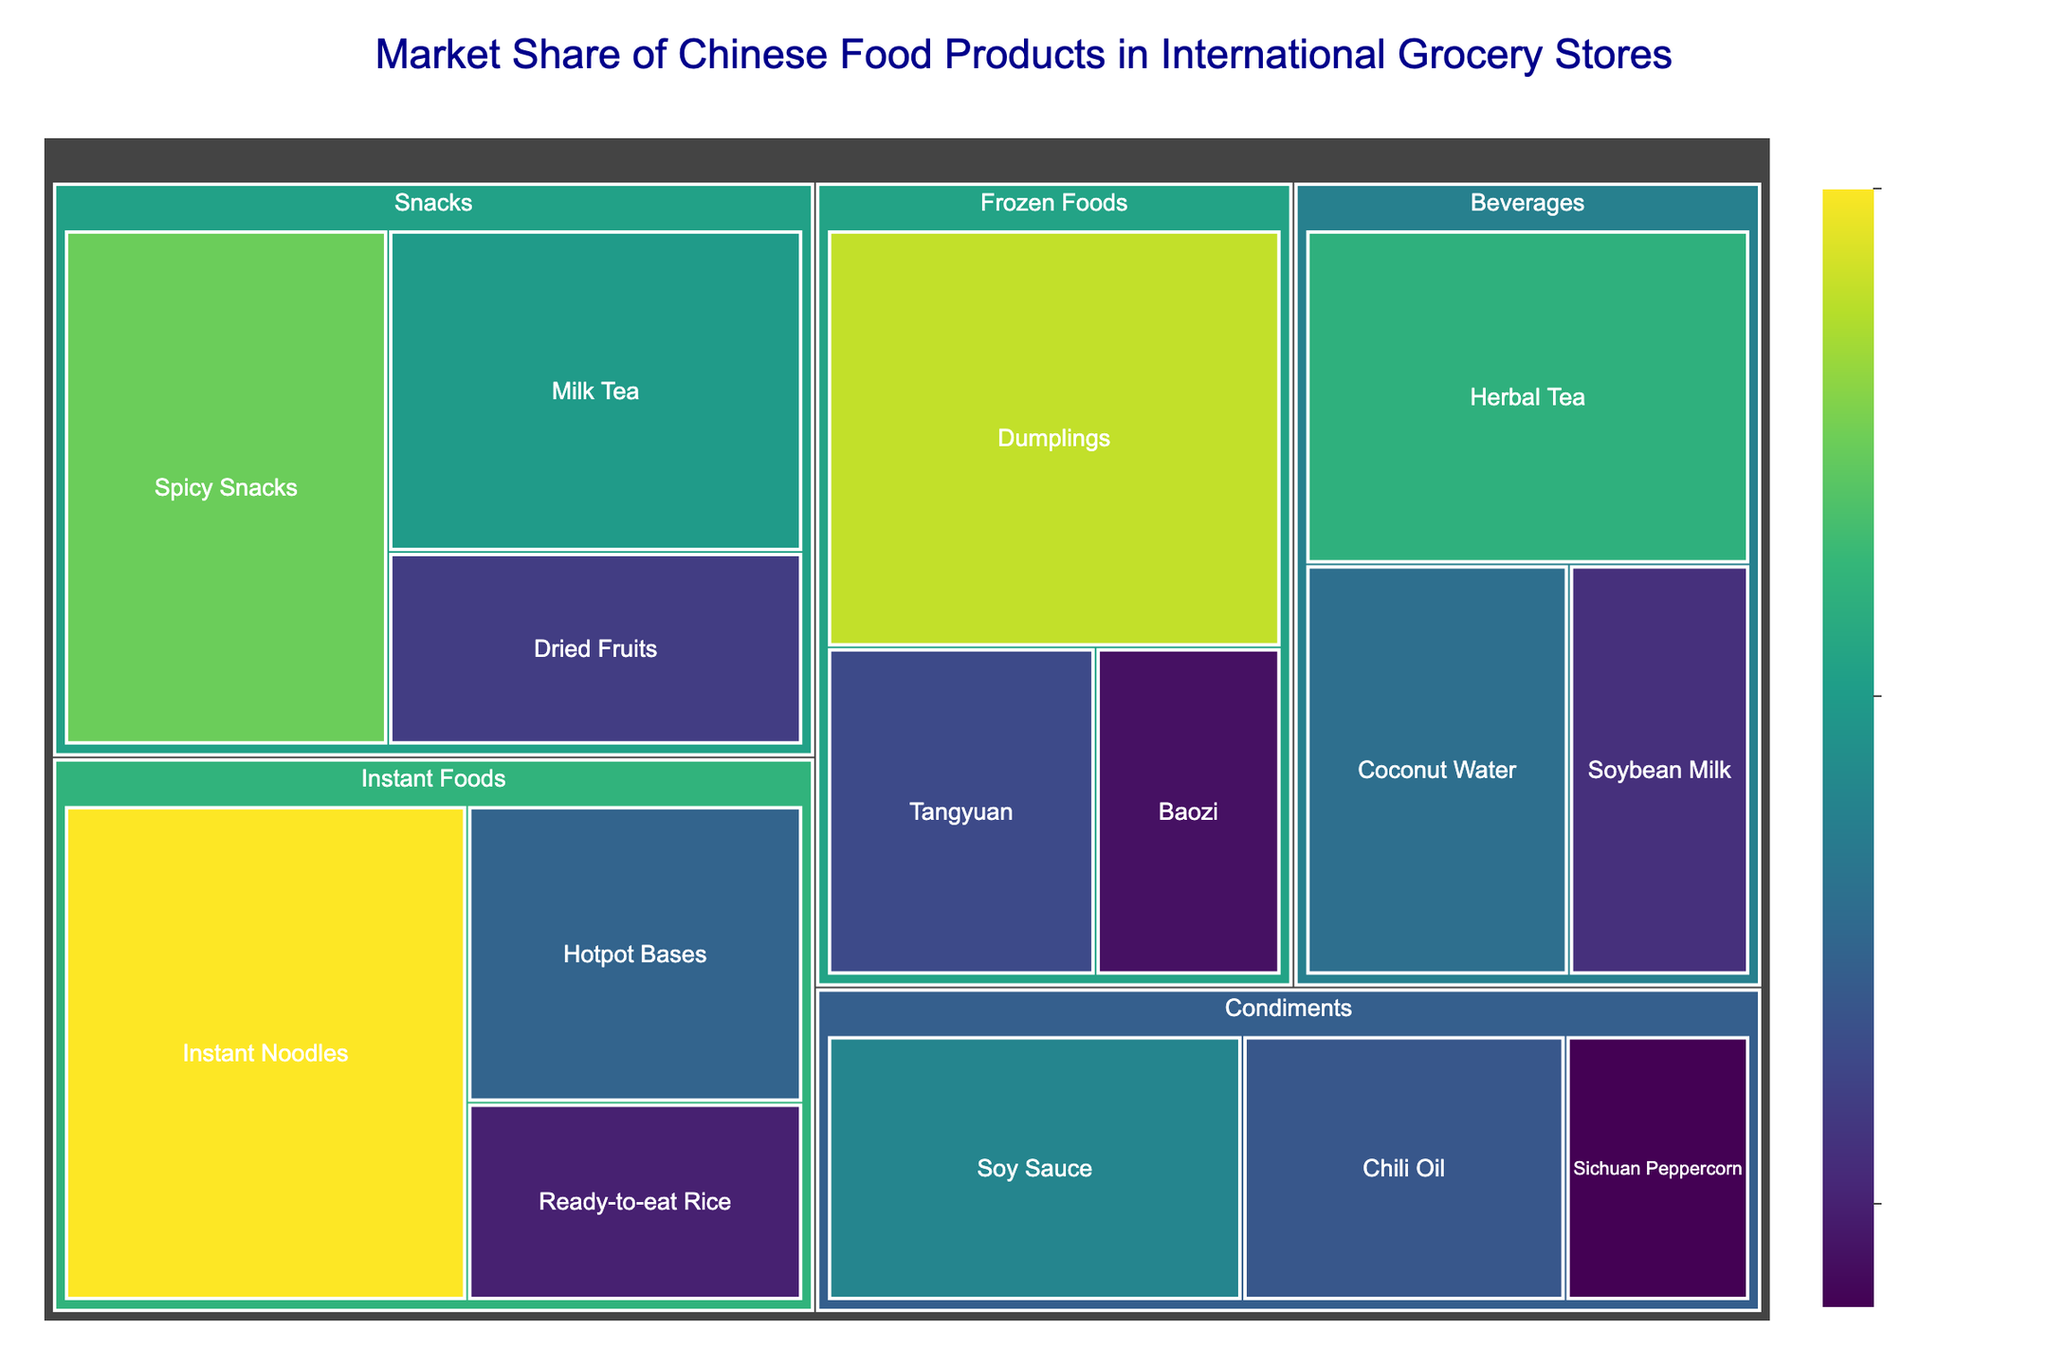Which subcategory in the "Instant Foods" category has the highest market share? To find the answer, locate the "Instant Foods" category in the treemap and identify the subcategory with the largest area. "Instant Noodles" has the largest share within "Instant Foods."
Answer: Instant Noodles How does the market share of "Spicy Snacks" compare to that of "Instant Noodles"? Compare the market share values for "Spicy Snacks" and "Instant Noodles." The market share of "Instant Noodles" is 30%, while "Spicy Snacks" is 25%. Therefore, "Instant Noodles" has a higher market share.
Answer: Instant Noodles > Spicy Snacks What is the total market share of all "Frozen Foods" subcategories combined? Add the market shares of all subcategories within the "Frozen Foods" category: Dumplings (28%), Tangyuan (13%), and Baozi (9%). The sum is 28 + 13 + 9 = 50%.
Answer: 50% Which subcategory has a greater market share: "Herbal Tea" or "Coconut Water"? To determine which subcategory has a greater market share, compare their values. "Herbal Tea" has a market share of 22%, and "Coconut Water" has 16%. Therefore, "Herbal Tea" has a greater market share.
Answer: Herbal Tea What is the average market share of the "Condiments" subcategories? Calculate the average market share of the subcategories within "Condiments" by summing their values and dividing by the number of subcategories. Soy Sauce (18%), Chili Oil (14%), and Sichuan Peppercorn (8%). The sum is 18 + 14 + 8 = 40%. There are 3 subcategories, so the average is 40 / 3 ≈ 13.33%.
Answer: ~13.33% Which has a higher combined market share: "Snacks" or "Beverages"? Calculate the total market share for each category. Snacks: Spicy Snacks (25%), Milk Tea (20%), Dried Fruits (12%). Sum is 25 + 20 + 12 = 57%. Beverages: Herbal Tea (22%), Coconut Water (16%), Soybean Milk (11%). Sum is 22 + 16 + 11 = 49%. Therefore, "Snacks" has a higher combined market share.
Answer: Snacks In how many categories is the highest market share subcategory greater than 20%? Count the number of categories where the top subcategory has a value greater than 20%. Categories with such subcategories include "Instant Foods" (Instant Noodles: 30%), "Snacks" (Spicy Snacks: 25%), "Beverages" (Herbal Tea: 22%), and "Frozen Foods" (Dumplings: 28%). There are 4 such categories.
Answer: 4 Which subcategory within "Condiments" has the lowest market share? Identify the subcategory with the smallest area within the "Condiments" category. "Sichuan Peppercorn" has a market share of 8%, which is the lowest among "Condiments."
Answer: Sichuan Peppercorn 